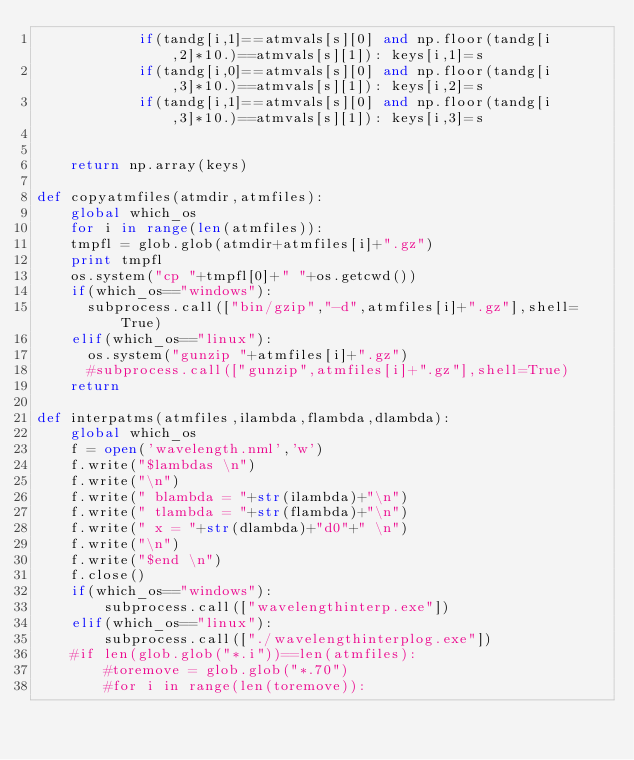Convert code to text. <code><loc_0><loc_0><loc_500><loc_500><_Python_>            if(tandg[i,1]==atmvals[s][0] and np.floor(tandg[i,2]*10.)==atmvals[s][1]): keys[i,1]=s
            if(tandg[i,0]==atmvals[s][0] and np.floor(tandg[i,3]*10.)==atmvals[s][1]): keys[i,2]=s
            if(tandg[i,1]==atmvals[s][0] and np.floor(tandg[i,3]*10.)==atmvals[s][1]): keys[i,3]=s
                

    return np.array(keys)

def copyatmfiles(atmdir,atmfiles):
    global which_os
    for i in range(len(atmfiles)):
		tmpfl = glob.glob(atmdir+atmfiles[i]+".gz")
		print tmpfl
		os.system("cp "+tmpfl[0]+" "+os.getcwd())
		if(which_os=="windows"):
			subprocess.call(["bin/gzip","-d",atmfiles[i]+".gz"],shell=True)
		elif(which_os=="linux"):
			os.system("gunzip "+atmfiles[i]+".gz")
			#subprocess.call(["gunzip",atmfiles[i]+".gz"],shell=True)
    return
    
def interpatms(atmfiles,ilambda,flambda,dlambda):
    global which_os
    f = open('wavelength.nml','w')
    f.write("$lambdas \n")
    f.write("\n")
    f.write(" blambda = "+str(ilambda)+"\n")
    f.write(" tlambda = "+str(flambda)+"\n")
    f.write(" x = "+str(dlambda)+"d0"+" \n")
    f.write("\n")
    f.write("$end \n")
    f.close()
    if(which_os=="windows"):
        subprocess.call(["wavelengthinterp.exe"])
    elif(which_os=="linux"):
        subprocess.call(["./wavelengthinterplog.exe"])
    #if len(glob.glob("*.i"))==len(atmfiles):
        #toremove = glob.glob("*.70")
        #for i in range(len(toremove)):</code> 